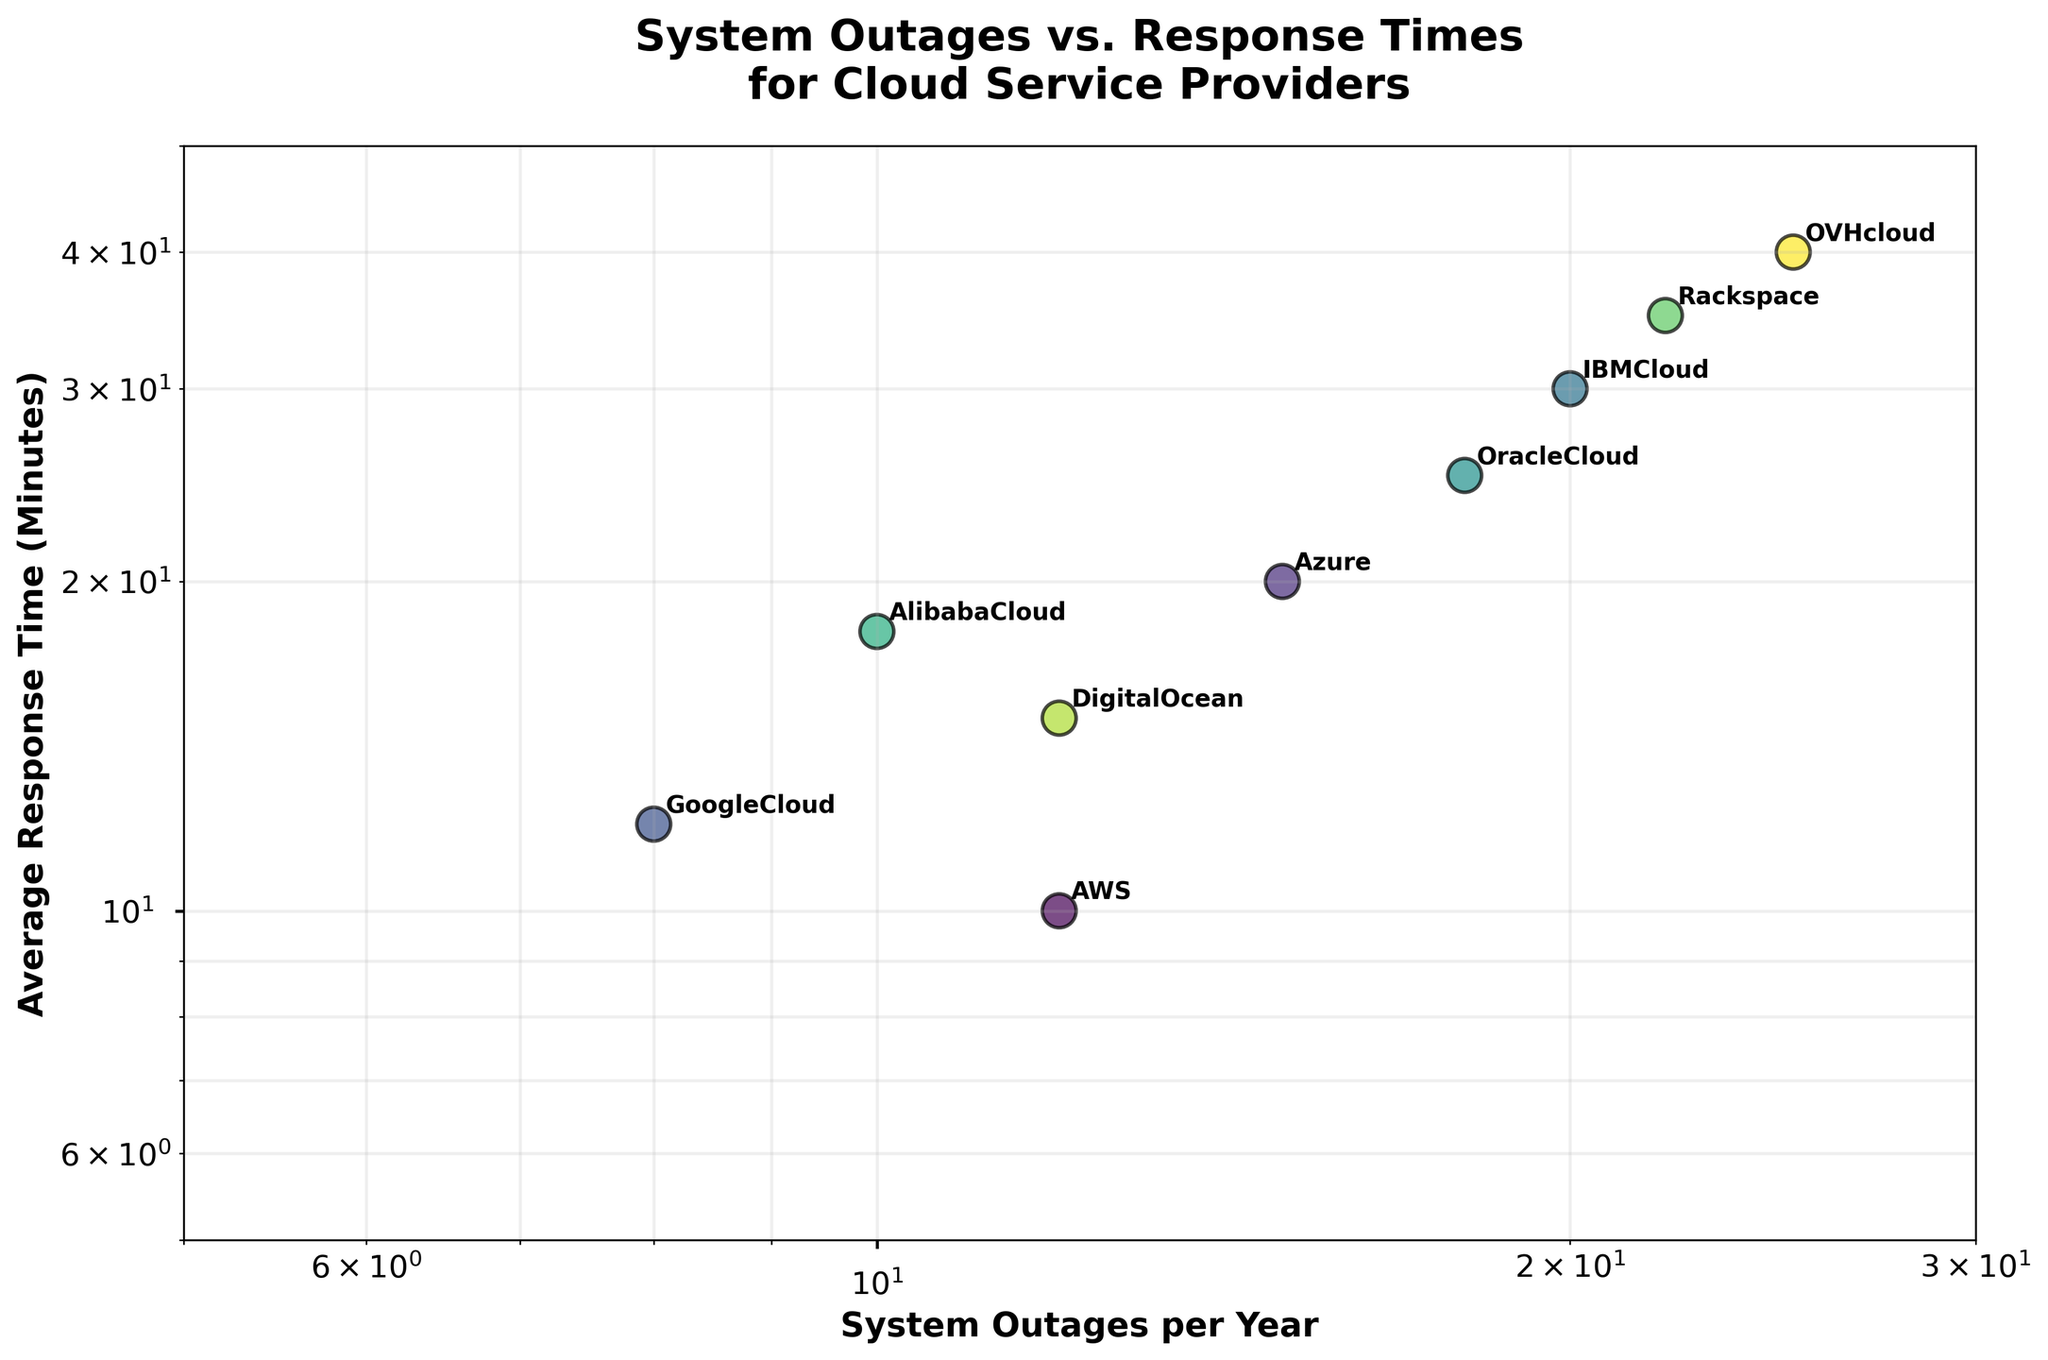What's the title of the figure? The title of the figure is typically situated at the top. In this case, it reads "System Outages vs. Response Times for Cloud Service Providers".
Answer: System Outages vs. Response Times for Cloud Service Providers Which cloud provider has the highest number of system outages per year? By looking at the x-axis (System Outages per Year) and finding the highest value, OVHcloud is the provider with the most outages, indicated at 25 outages per year.
Answer: OVHcloud Which cloud provider has the lowest average response time? By examining the y-axis (Average Response Time in Minutes) and finding the smallest value point, AWS has the lowest response time at 10 minutes.
Answer: AWS How many cloud providers experience more than 20 system outages per year? Inspect the x-axis and count the points that fall to the right of the 20 mark. There are three such points: IBM Cloud, Rackspace, and OVHcloud.
Answer: 3 Which cloud provider has the highest average response time? Observing the y-axis (Average Response Time in Minutes), OVHcloud is identified as the provider with the highest response time at 40 minutes.
Answer: OVHcloud Among AWS, Azure, and Google Cloud, which has the highest average response time? Locate the positions for AWS, Azure, and Google Cloud on the y-axis. Azure has the highest response time of 20 minutes among these three.
Answer: Azure Is there a cloud provider with more than 10 system outages per year and an average response time less than 20 minutes? Identify the points where the x-axis value is greater than 10, and the y-axis value is less than 20. AWS and DigitalOcean fit this criterion, with AWS having 12 outages and a response time of 10 minutes, and DigitalOcean having 12 outages and a response time of 15 minutes.
Answer: Yes What are the coordinates for IBM Cloud in terms of system outages and response times? IBM Cloud's position on the plot can be confirmed based on its x-axis value (20 system outages per year) and y-axis value (30 average response time in minutes).
Answer: (20, 30) Which cloud provider has a better average response time, Alibaba Cloud or Oracle Cloud? Locate the points for both Alibaba Cloud and Oracle Cloud on the y-axis. Alibaba Cloud has a lower response time (18 minutes) compared to Oracle Cloud (25 minutes).
Answer: Alibaba Cloud How many cloud providers have average response times between 10 and 20 minutes? Examine the y-axis values that fall between 10 and 20. There are five such points: AWS (10), Google Cloud (12), DigitalOcean (15), Azure (20), and Alibaba Cloud (18).
Answer: 5 